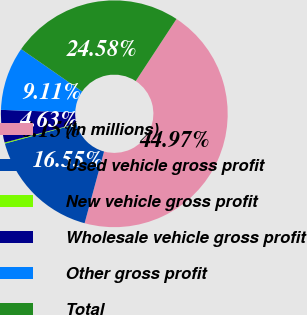<chart> <loc_0><loc_0><loc_500><loc_500><pie_chart><fcel>(In millions)<fcel>Used vehicle gross profit<fcel>New vehicle gross profit<fcel>Wholesale vehicle gross profit<fcel>Other gross profit<fcel>Total<nl><fcel>44.97%<fcel>16.55%<fcel>0.15%<fcel>4.63%<fcel>9.11%<fcel>24.58%<nl></chart> 